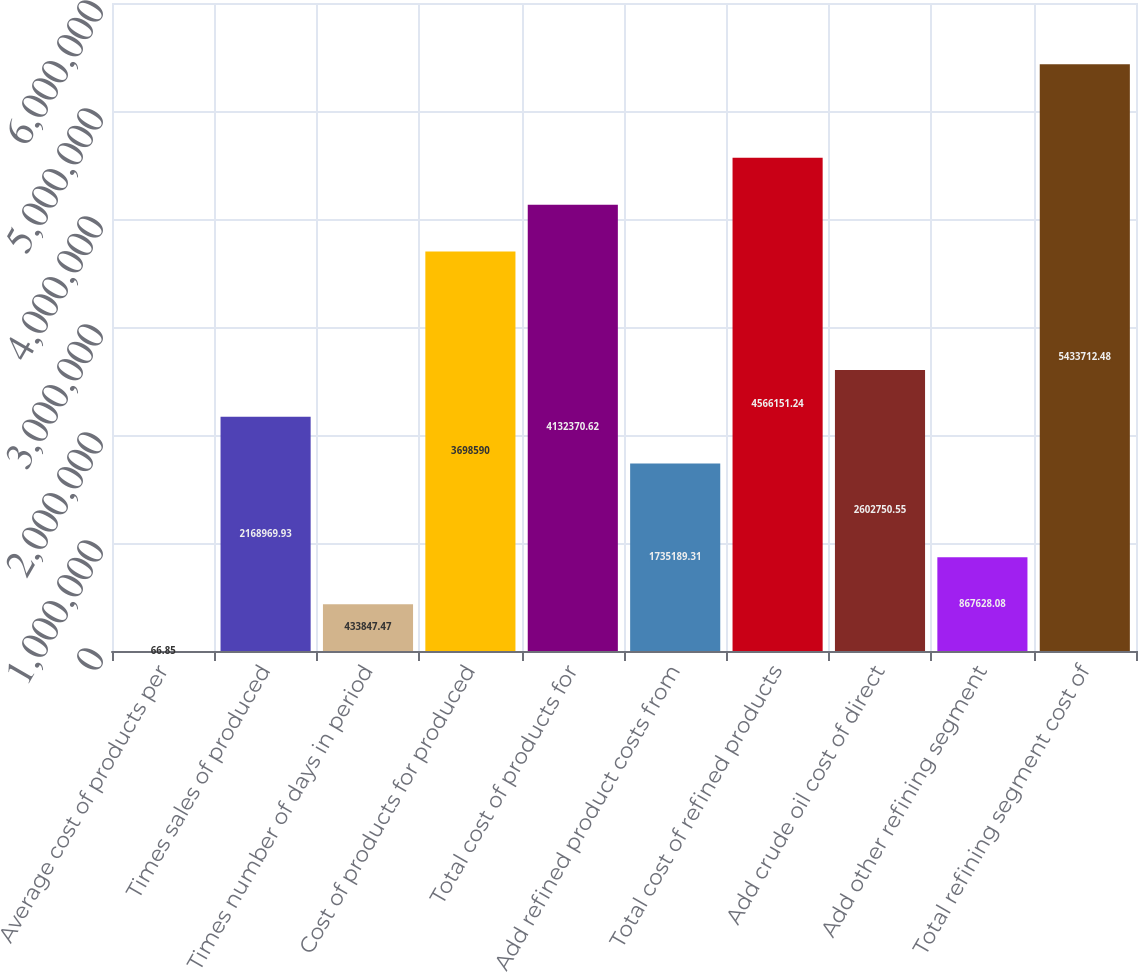<chart> <loc_0><loc_0><loc_500><loc_500><bar_chart><fcel>Average cost of products per<fcel>Times sales of produced<fcel>Times number of days in period<fcel>Cost of products for produced<fcel>Total cost of products for<fcel>Add refined product costs from<fcel>Total cost of refined products<fcel>Add crude oil cost of direct<fcel>Add other refining segment<fcel>Total refining segment cost of<nl><fcel>66.85<fcel>2.16897e+06<fcel>433847<fcel>3.69859e+06<fcel>4.13237e+06<fcel>1.73519e+06<fcel>4.56615e+06<fcel>2.60275e+06<fcel>867628<fcel>5.43371e+06<nl></chart> 